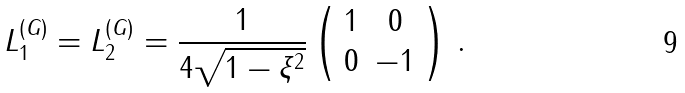<formula> <loc_0><loc_0><loc_500><loc_500>L _ { 1 } ^ { ( G ) } = L _ { 2 } ^ { ( G ) } = \frac { 1 } { 4 \sqrt { 1 - \xi ^ { 2 } } } \left ( \begin{array} { c c } 1 & 0 \\ 0 & - 1 \end{array} \right ) \, .</formula> 